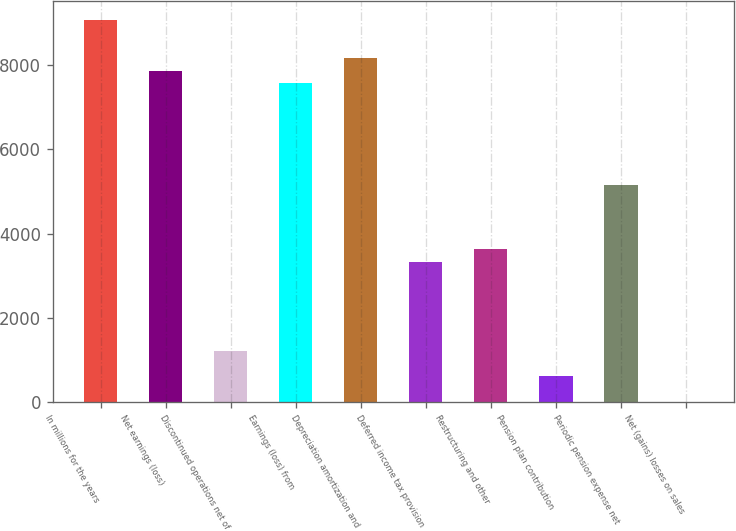Convert chart to OTSL. <chart><loc_0><loc_0><loc_500><loc_500><bar_chart><fcel>In millions for the years<fcel>Net earnings (loss)<fcel>Discontinued operations net of<fcel>Earnings (loss) from<fcel>Depreciation amortization and<fcel>Deferred income tax provision<fcel>Restructuring and other<fcel>Pension plan contribution<fcel>Periodic pension expense net<fcel>Net (gains) losses on sales<nl><fcel>9078<fcel>7868<fcel>1213<fcel>7565.5<fcel>8170.5<fcel>3330.5<fcel>3633<fcel>608<fcel>5145.5<fcel>3<nl></chart> 